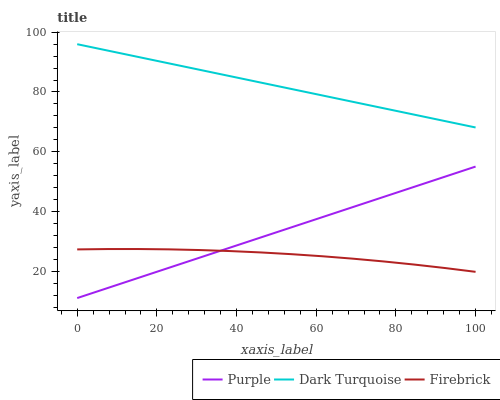Does Firebrick have the minimum area under the curve?
Answer yes or no. Yes. Does Dark Turquoise have the maximum area under the curve?
Answer yes or no. Yes. Does Dark Turquoise have the minimum area under the curve?
Answer yes or no. No. Does Firebrick have the maximum area under the curve?
Answer yes or no. No. Is Purple the smoothest?
Answer yes or no. Yes. Is Firebrick the roughest?
Answer yes or no. Yes. Is Dark Turquoise the smoothest?
Answer yes or no. No. Is Dark Turquoise the roughest?
Answer yes or no. No. Does Purple have the lowest value?
Answer yes or no. Yes. Does Firebrick have the lowest value?
Answer yes or no. No. Does Dark Turquoise have the highest value?
Answer yes or no. Yes. Does Firebrick have the highest value?
Answer yes or no. No. Is Purple less than Dark Turquoise?
Answer yes or no. Yes. Is Dark Turquoise greater than Purple?
Answer yes or no. Yes. Does Purple intersect Firebrick?
Answer yes or no. Yes. Is Purple less than Firebrick?
Answer yes or no. No. Is Purple greater than Firebrick?
Answer yes or no. No. Does Purple intersect Dark Turquoise?
Answer yes or no. No. 